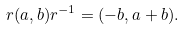Convert formula to latex. <formula><loc_0><loc_0><loc_500><loc_500>r ( a , b ) r ^ { - 1 } = ( - b , a + b ) .</formula> 